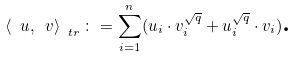Convert formula to latex. <formula><loc_0><loc_0><loc_500><loc_500>\left \langle \ u , \ v \right \rangle _ { \ t r } \colon = \sum _ { i = 1 } ^ { n } ( u _ { i } \cdot v _ { i } ^ { \sqrt { q } } + u _ { i } ^ { \sqrt { q } } \cdot v _ { i } ) \text {.}</formula> 